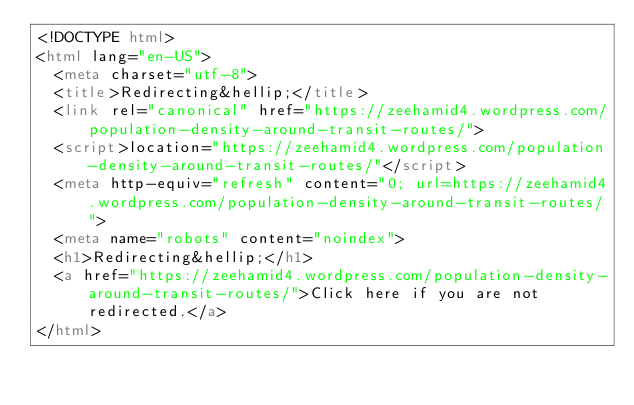<code> <loc_0><loc_0><loc_500><loc_500><_HTML_><!DOCTYPE html>
<html lang="en-US">
  <meta charset="utf-8">
  <title>Redirecting&hellip;</title>
  <link rel="canonical" href="https://zeehamid4.wordpress.com/population-density-around-transit-routes/">
  <script>location="https://zeehamid4.wordpress.com/population-density-around-transit-routes/"</script>
  <meta http-equiv="refresh" content="0; url=https://zeehamid4.wordpress.com/population-density-around-transit-routes/">
  <meta name="robots" content="noindex">
  <h1>Redirecting&hellip;</h1>
  <a href="https://zeehamid4.wordpress.com/population-density-around-transit-routes/">Click here if you are not redirected.</a>
</html>
</code> 